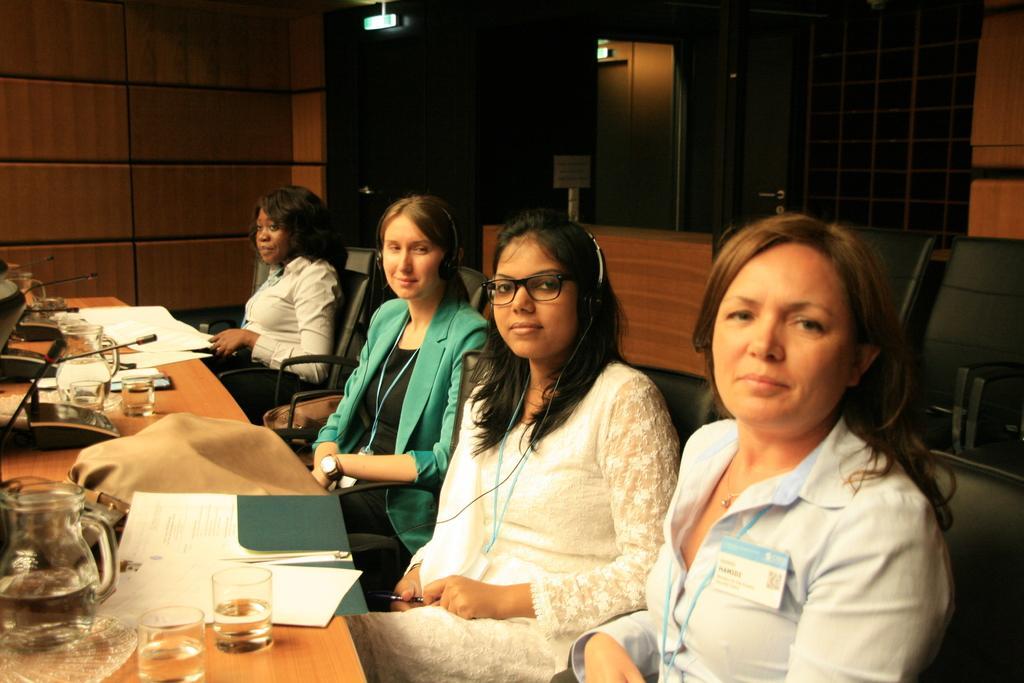In one or two sentences, can you explain what this image depicts? In the center of the image we can see four persons are sitting on the chair. And they are smiling, which we can see on their faces. In front of them, there is a table. On the table, we can see glasses, papers, microphones, one jar, one plate, one paper cover and a few other objects. In the background there is a wall, door, sign boards etc. 